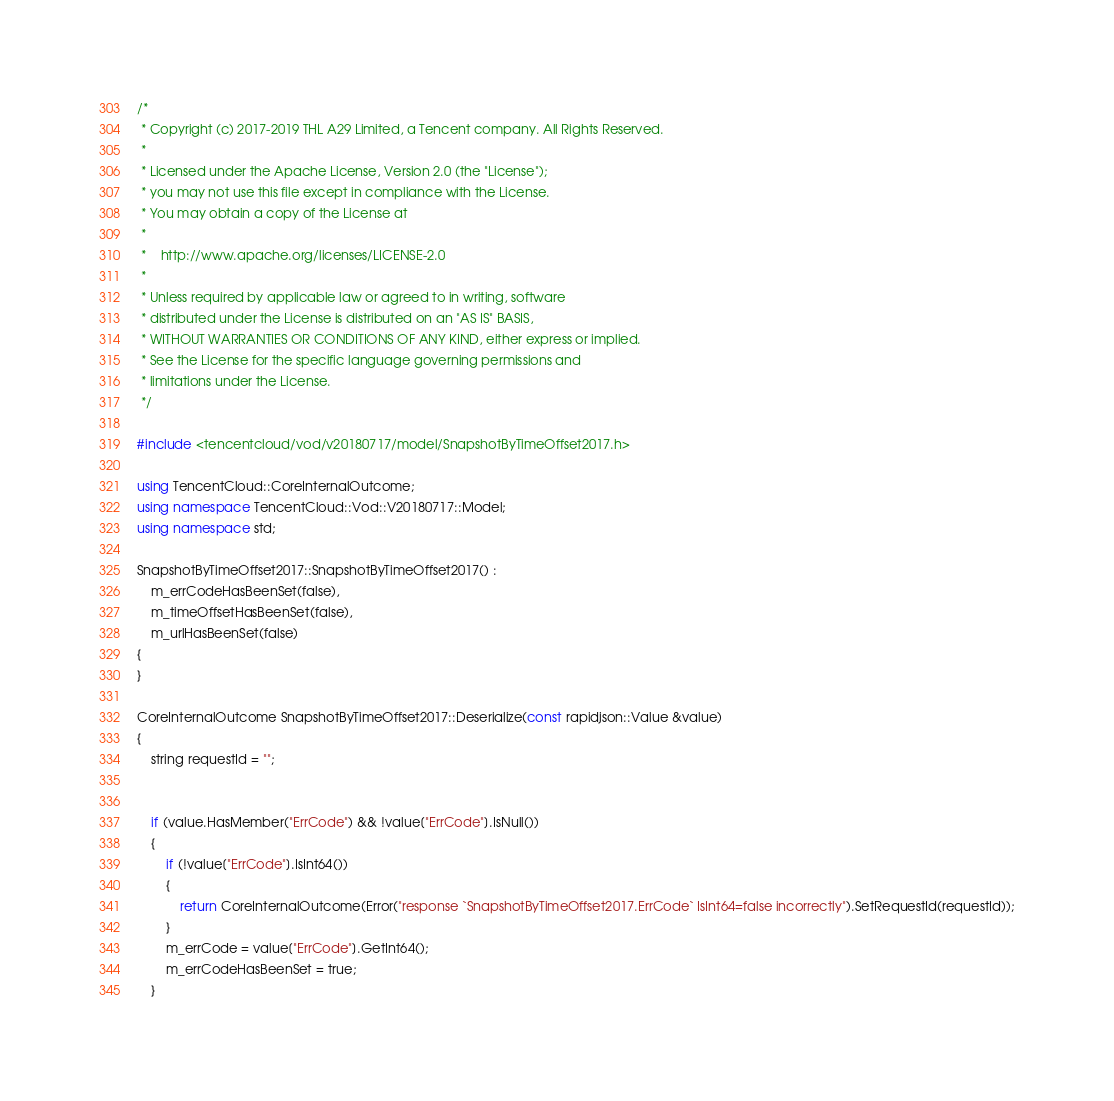<code> <loc_0><loc_0><loc_500><loc_500><_C++_>/*
 * Copyright (c) 2017-2019 THL A29 Limited, a Tencent company. All Rights Reserved.
 *
 * Licensed under the Apache License, Version 2.0 (the "License");
 * you may not use this file except in compliance with the License.
 * You may obtain a copy of the License at
 *
 *    http://www.apache.org/licenses/LICENSE-2.0
 *
 * Unless required by applicable law or agreed to in writing, software
 * distributed under the License is distributed on an "AS IS" BASIS,
 * WITHOUT WARRANTIES OR CONDITIONS OF ANY KIND, either express or implied.
 * See the License for the specific language governing permissions and
 * limitations under the License.
 */

#include <tencentcloud/vod/v20180717/model/SnapshotByTimeOffset2017.h>

using TencentCloud::CoreInternalOutcome;
using namespace TencentCloud::Vod::V20180717::Model;
using namespace std;

SnapshotByTimeOffset2017::SnapshotByTimeOffset2017() :
    m_errCodeHasBeenSet(false),
    m_timeOffsetHasBeenSet(false),
    m_urlHasBeenSet(false)
{
}

CoreInternalOutcome SnapshotByTimeOffset2017::Deserialize(const rapidjson::Value &value)
{
    string requestId = "";


    if (value.HasMember("ErrCode") && !value["ErrCode"].IsNull())
    {
        if (!value["ErrCode"].IsInt64())
        {
            return CoreInternalOutcome(Error("response `SnapshotByTimeOffset2017.ErrCode` IsInt64=false incorrectly").SetRequestId(requestId));
        }
        m_errCode = value["ErrCode"].GetInt64();
        m_errCodeHasBeenSet = true;
    }
</code> 